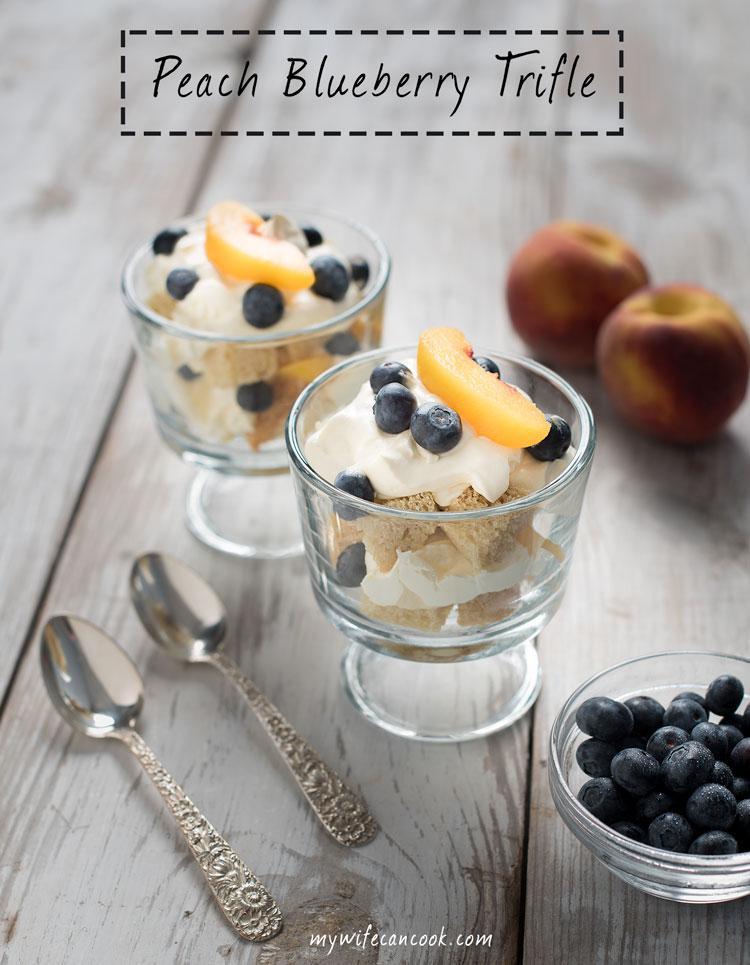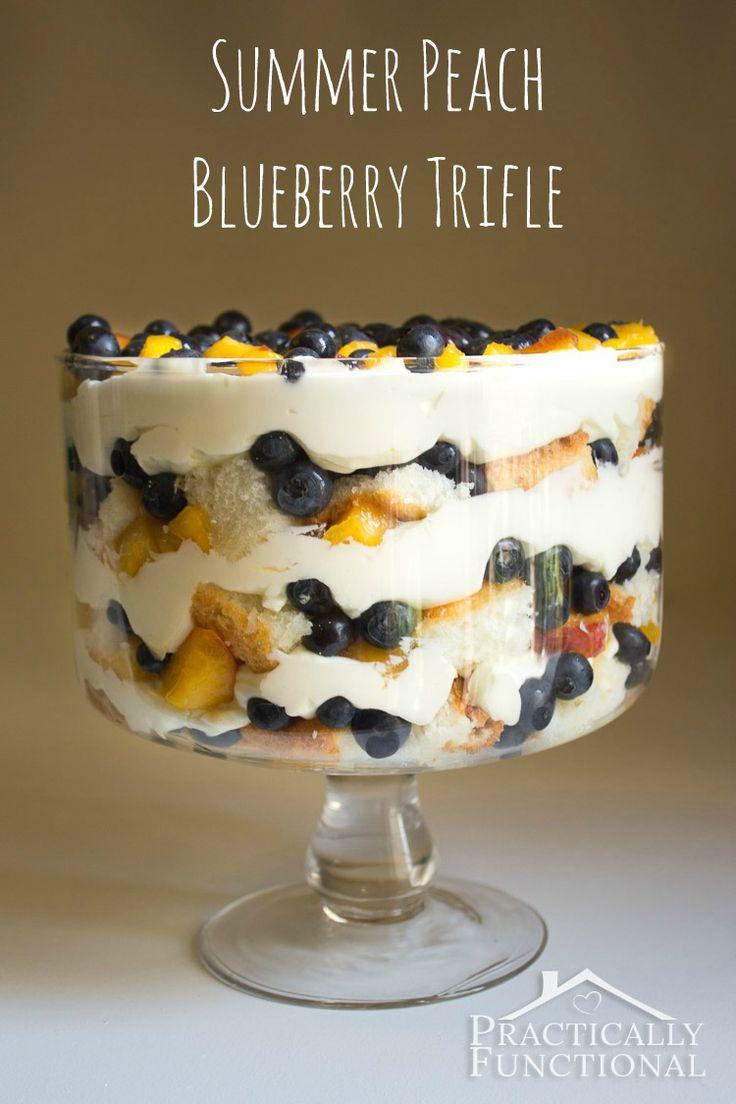The first image is the image on the left, the second image is the image on the right. Analyze the images presented: Is the assertion "There are one or more spoons to the left of the truffle in one of the images." valid? Answer yes or no. Yes. The first image is the image on the left, the second image is the image on the right. Considering the images on both sides, is "One image in the pair contains a whole piece of fruit." valid? Answer yes or no. Yes. 